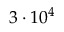Convert formula to latex. <formula><loc_0><loc_0><loc_500><loc_500>3 \cdot 1 0 ^ { 4 }</formula> 